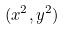Convert formula to latex. <formula><loc_0><loc_0><loc_500><loc_500>( x ^ { 2 } , y ^ { 2 } )</formula> 